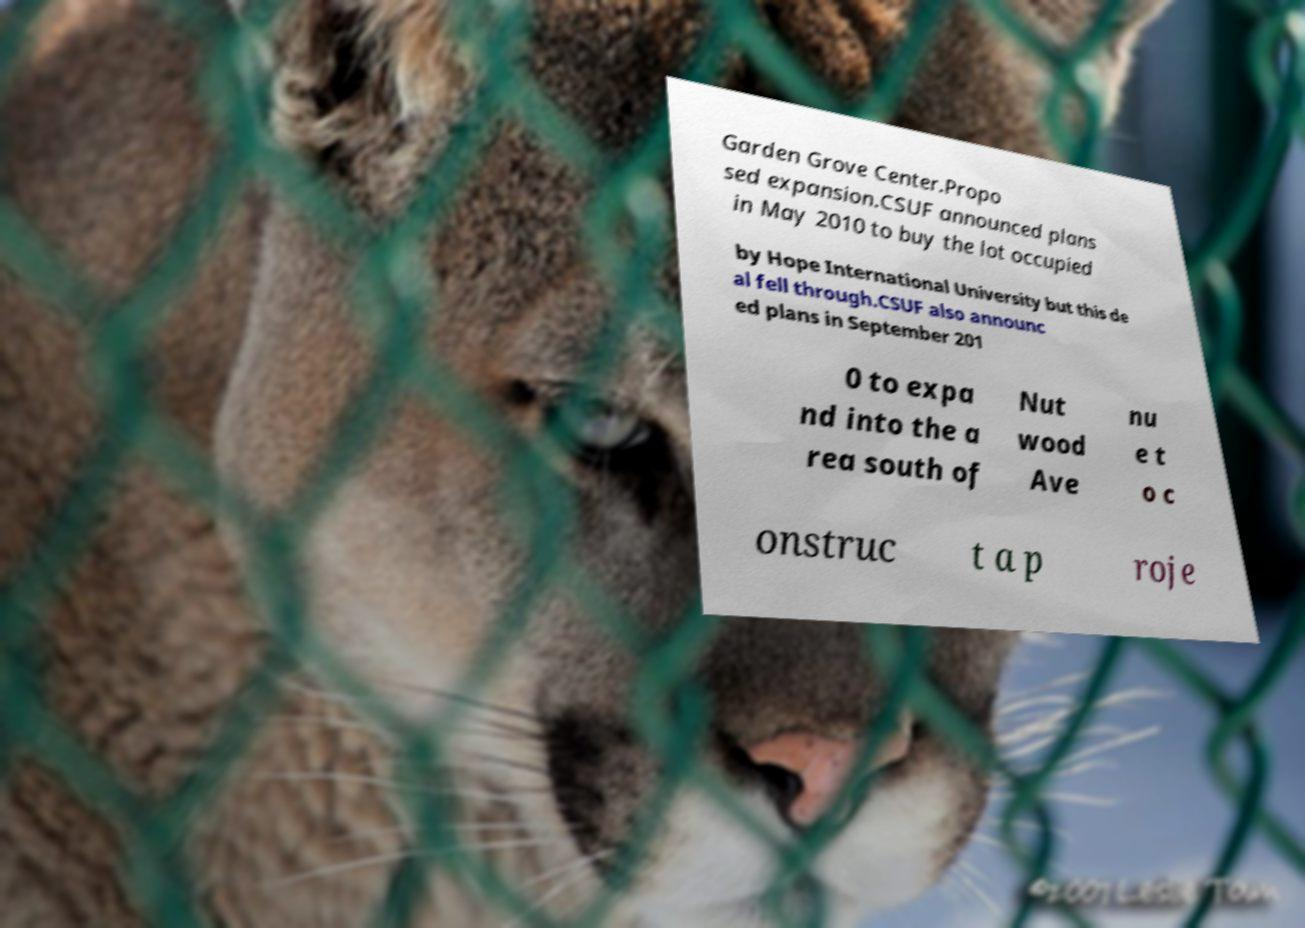Can you accurately transcribe the text from the provided image for me? Garden Grove Center.Propo sed expansion.CSUF announced plans in May 2010 to buy the lot occupied by Hope International University but this de al fell through.CSUF also announc ed plans in September 201 0 to expa nd into the a rea south of Nut wood Ave nu e t o c onstruc t a p roje 